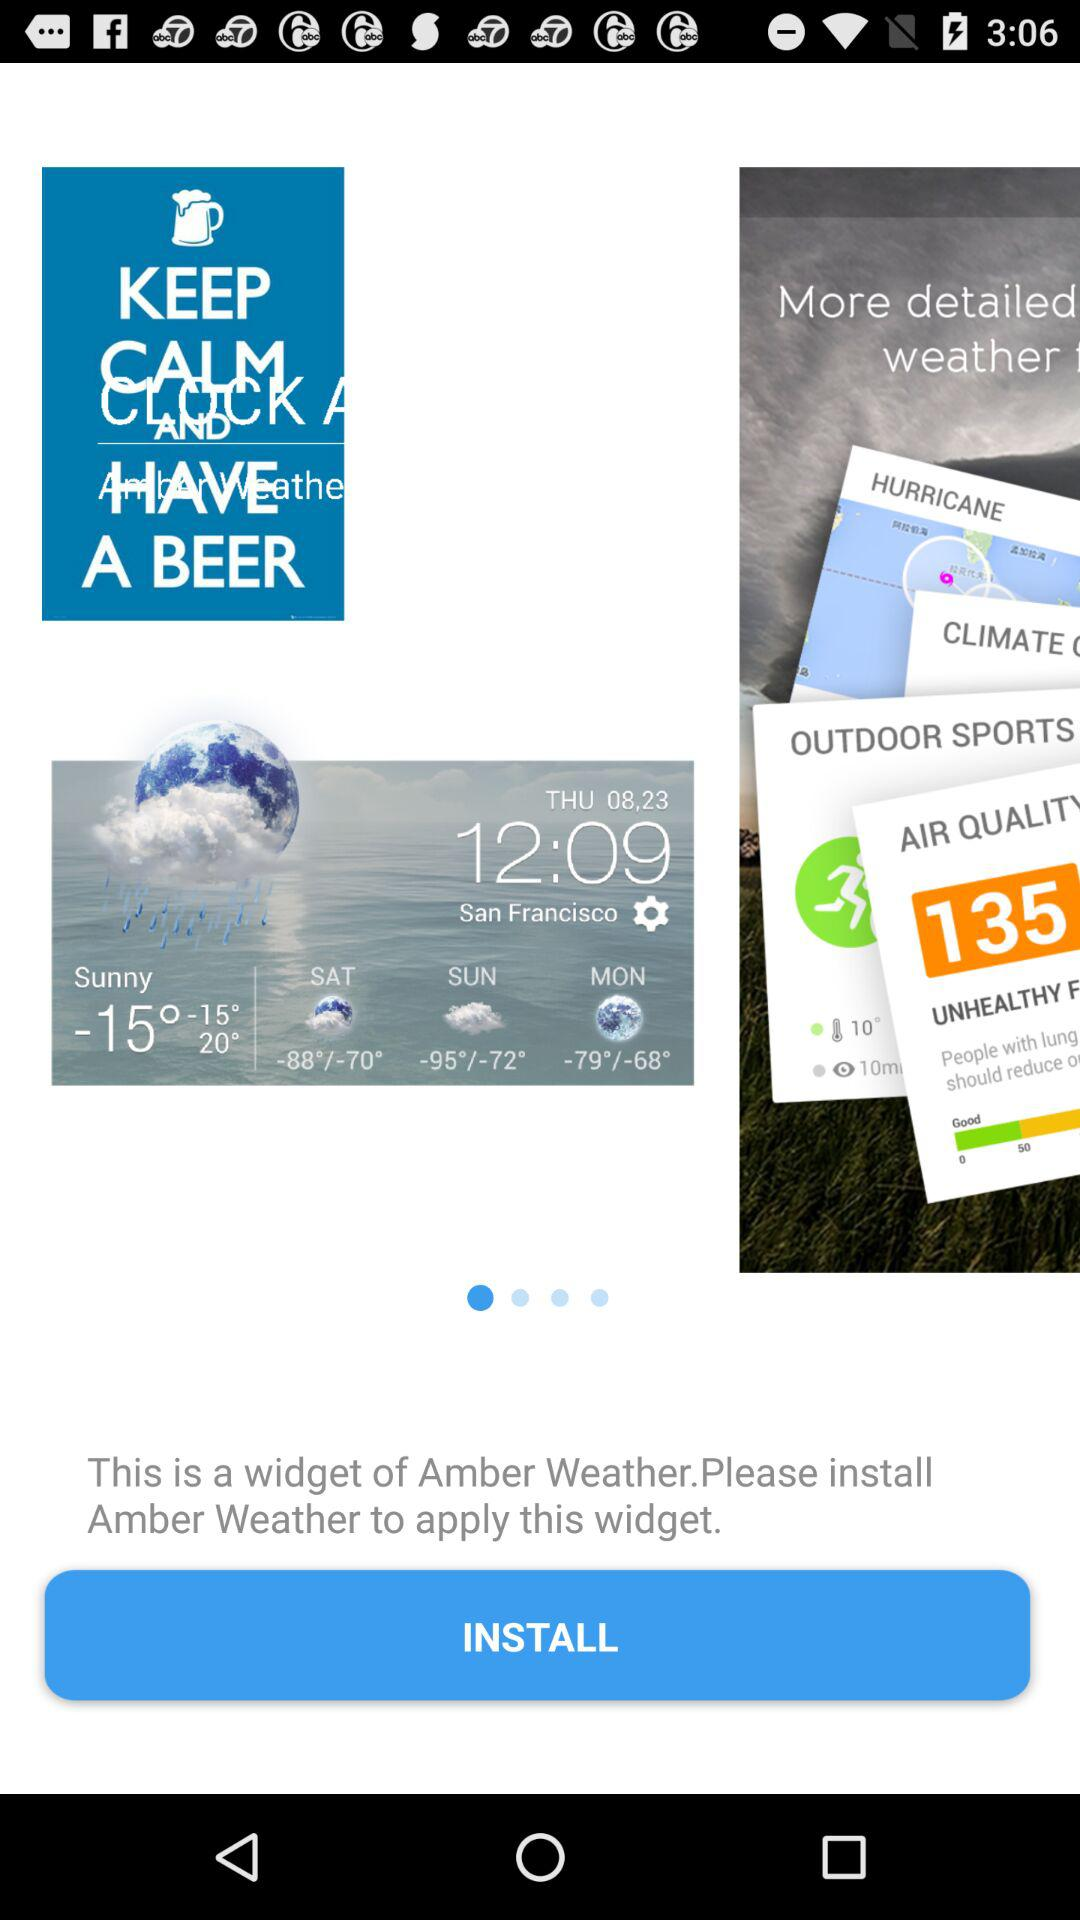What time is displayed on the screen? The time is 12:09. 